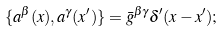<formula> <loc_0><loc_0><loc_500><loc_500>\{ a ^ { \beta } ( x ) , a ^ { \gamma } ( x ^ { \prime } ) \} = \bar { g } ^ { \beta \gamma } \delta ^ { \prime } ( x - x ^ { \prime } ) ;</formula> 